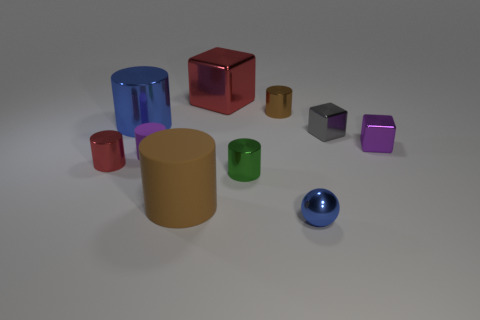Subtract all blue spheres. How many brown cylinders are left? 2 Subtract 2 cylinders. How many cylinders are left? 4 Subtract all small shiny cubes. How many cubes are left? 1 Subtract all green cylinders. How many cylinders are left? 5 Subtract all brown cylinders. Subtract all brown blocks. How many cylinders are left? 4 Subtract all blocks. How many objects are left? 7 Subtract all metallic blocks. Subtract all red shiny blocks. How many objects are left? 6 Add 4 rubber things. How many rubber things are left? 6 Add 9 small brown cubes. How many small brown cubes exist? 9 Subtract 0 green cubes. How many objects are left? 10 